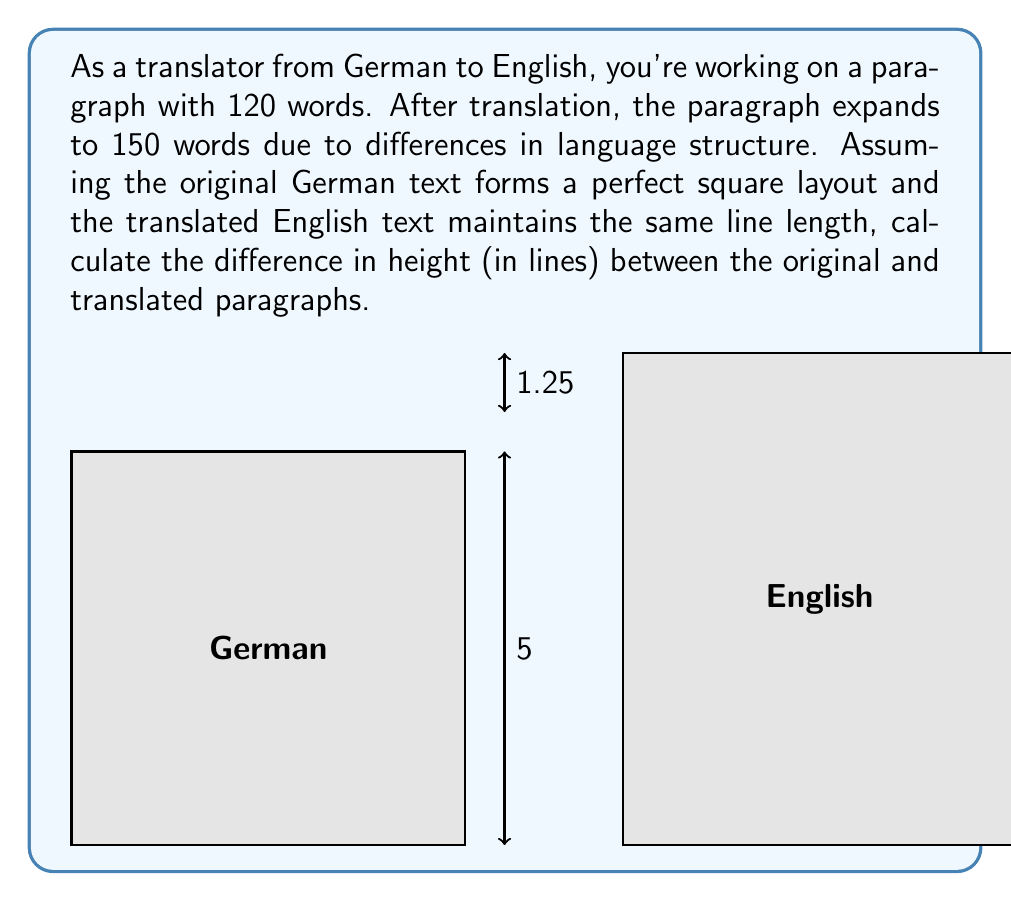Teach me how to tackle this problem. Let's approach this step-by-step:

1) For the German text:
   - Total words: 120
   - Perfect square layout means: $\sqrt{120} = 10.95$ (rounded to 11 words per side)
   - So, it's an 11x11 word square

2) For the English text:
   - Total words: 150
   - Same line length as German: 11 words per line
   - Number of lines: $150 \div 11 = 13.64$ (rounded up to 14 lines)

3) Calculate the difference in height:
   - German height: 11 lines
   - English height: 14 lines
   - Difference: $14 - 11 = 3$ lines

Therefore, the translated English paragraph is 3 lines taller than the original German paragraph.
Answer: 3 lines 